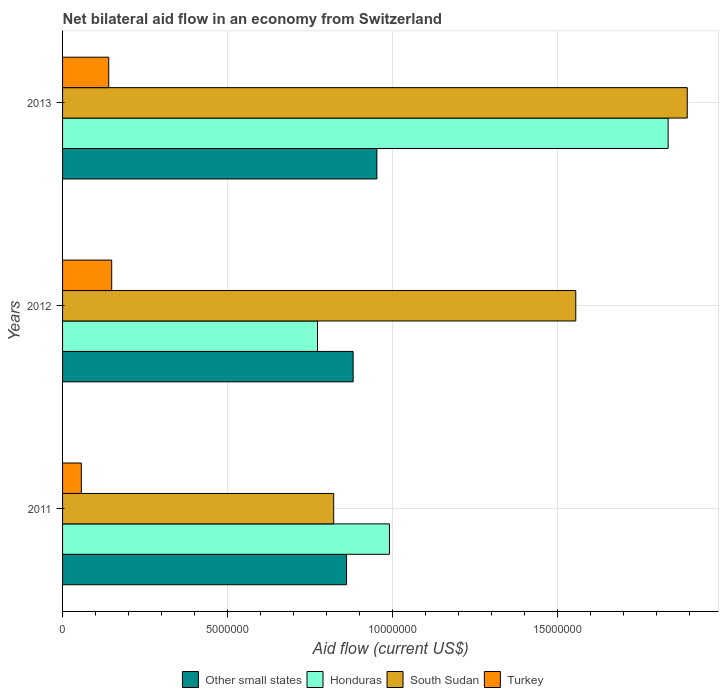How many groups of bars are there?
Provide a succinct answer. 3. Are the number of bars per tick equal to the number of legend labels?
Ensure brevity in your answer.  Yes. How many bars are there on the 3rd tick from the top?
Your answer should be compact. 4. How many bars are there on the 1st tick from the bottom?
Your answer should be compact. 4. What is the label of the 1st group of bars from the top?
Offer a terse response. 2013. What is the net bilateral aid flow in South Sudan in 2013?
Offer a terse response. 1.89e+07. Across all years, what is the maximum net bilateral aid flow in Honduras?
Offer a terse response. 1.84e+07. Across all years, what is the minimum net bilateral aid flow in Other small states?
Offer a very short reply. 8.61e+06. What is the total net bilateral aid flow in Honduras in the graph?
Provide a succinct answer. 3.60e+07. What is the difference between the net bilateral aid flow in Turkey in 2011 and that in 2013?
Your answer should be very brief. -8.30e+05. What is the difference between the net bilateral aid flow in Turkey in 2011 and the net bilateral aid flow in Honduras in 2012?
Ensure brevity in your answer.  -7.16e+06. In the year 2013, what is the difference between the net bilateral aid flow in Turkey and net bilateral aid flow in Honduras?
Your response must be concise. -1.70e+07. In how many years, is the net bilateral aid flow in South Sudan greater than 8000000 US$?
Give a very brief answer. 3. What is the ratio of the net bilateral aid flow in Turkey in 2011 to that in 2012?
Your answer should be very brief. 0.38. Is the net bilateral aid flow in South Sudan in 2011 less than that in 2013?
Provide a succinct answer. Yes. Is the difference between the net bilateral aid flow in Turkey in 2012 and 2013 greater than the difference between the net bilateral aid flow in Honduras in 2012 and 2013?
Your answer should be compact. Yes. What is the difference between the highest and the second highest net bilateral aid flow in Honduras?
Make the answer very short. 8.45e+06. What is the difference between the highest and the lowest net bilateral aid flow in South Sudan?
Offer a very short reply. 1.07e+07. What does the 4th bar from the top in 2011 represents?
Your response must be concise. Other small states. Is it the case that in every year, the sum of the net bilateral aid flow in Turkey and net bilateral aid flow in Honduras is greater than the net bilateral aid flow in Other small states?
Your answer should be compact. Yes. Are all the bars in the graph horizontal?
Make the answer very short. Yes. What is the difference between two consecutive major ticks on the X-axis?
Make the answer very short. 5.00e+06. Are the values on the major ticks of X-axis written in scientific E-notation?
Ensure brevity in your answer.  No. Does the graph contain grids?
Your answer should be very brief. Yes. Where does the legend appear in the graph?
Provide a short and direct response. Bottom center. How are the legend labels stacked?
Keep it short and to the point. Horizontal. What is the title of the graph?
Your answer should be compact. Net bilateral aid flow in an economy from Switzerland. What is the label or title of the Y-axis?
Keep it short and to the point. Years. What is the Aid flow (current US$) in Other small states in 2011?
Ensure brevity in your answer.  8.61e+06. What is the Aid flow (current US$) in Honduras in 2011?
Ensure brevity in your answer.  9.91e+06. What is the Aid flow (current US$) in South Sudan in 2011?
Your answer should be very brief. 8.22e+06. What is the Aid flow (current US$) in Turkey in 2011?
Keep it short and to the point. 5.70e+05. What is the Aid flow (current US$) of Other small states in 2012?
Your answer should be compact. 8.81e+06. What is the Aid flow (current US$) of Honduras in 2012?
Provide a succinct answer. 7.73e+06. What is the Aid flow (current US$) of South Sudan in 2012?
Make the answer very short. 1.56e+07. What is the Aid flow (current US$) of Turkey in 2012?
Your answer should be very brief. 1.49e+06. What is the Aid flow (current US$) in Other small states in 2013?
Your response must be concise. 9.53e+06. What is the Aid flow (current US$) of Honduras in 2013?
Your response must be concise. 1.84e+07. What is the Aid flow (current US$) of South Sudan in 2013?
Provide a short and direct response. 1.89e+07. What is the Aid flow (current US$) in Turkey in 2013?
Your response must be concise. 1.40e+06. Across all years, what is the maximum Aid flow (current US$) in Other small states?
Offer a very short reply. 9.53e+06. Across all years, what is the maximum Aid flow (current US$) of Honduras?
Provide a short and direct response. 1.84e+07. Across all years, what is the maximum Aid flow (current US$) in South Sudan?
Provide a short and direct response. 1.89e+07. Across all years, what is the maximum Aid flow (current US$) in Turkey?
Give a very brief answer. 1.49e+06. Across all years, what is the minimum Aid flow (current US$) in Other small states?
Ensure brevity in your answer.  8.61e+06. Across all years, what is the minimum Aid flow (current US$) of Honduras?
Offer a very short reply. 7.73e+06. Across all years, what is the minimum Aid flow (current US$) in South Sudan?
Give a very brief answer. 8.22e+06. Across all years, what is the minimum Aid flow (current US$) in Turkey?
Make the answer very short. 5.70e+05. What is the total Aid flow (current US$) of Other small states in the graph?
Your answer should be very brief. 2.70e+07. What is the total Aid flow (current US$) in Honduras in the graph?
Keep it short and to the point. 3.60e+07. What is the total Aid flow (current US$) in South Sudan in the graph?
Offer a very short reply. 4.27e+07. What is the total Aid flow (current US$) in Turkey in the graph?
Keep it short and to the point. 3.46e+06. What is the difference between the Aid flow (current US$) in Honduras in 2011 and that in 2012?
Your answer should be compact. 2.18e+06. What is the difference between the Aid flow (current US$) in South Sudan in 2011 and that in 2012?
Keep it short and to the point. -7.34e+06. What is the difference between the Aid flow (current US$) in Turkey in 2011 and that in 2012?
Your response must be concise. -9.20e+05. What is the difference between the Aid flow (current US$) in Other small states in 2011 and that in 2013?
Your response must be concise. -9.20e+05. What is the difference between the Aid flow (current US$) of Honduras in 2011 and that in 2013?
Offer a terse response. -8.45e+06. What is the difference between the Aid flow (current US$) of South Sudan in 2011 and that in 2013?
Your answer should be compact. -1.07e+07. What is the difference between the Aid flow (current US$) in Turkey in 2011 and that in 2013?
Offer a very short reply. -8.30e+05. What is the difference between the Aid flow (current US$) of Other small states in 2012 and that in 2013?
Provide a short and direct response. -7.20e+05. What is the difference between the Aid flow (current US$) in Honduras in 2012 and that in 2013?
Keep it short and to the point. -1.06e+07. What is the difference between the Aid flow (current US$) of South Sudan in 2012 and that in 2013?
Keep it short and to the point. -3.38e+06. What is the difference between the Aid flow (current US$) in Other small states in 2011 and the Aid flow (current US$) in Honduras in 2012?
Keep it short and to the point. 8.80e+05. What is the difference between the Aid flow (current US$) of Other small states in 2011 and the Aid flow (current US$) of South Sudan in 2012?
Your answer should be compact. -6.95e+06. What is the difference between the Aid flow (current US$) of Other small states in 2011 and the Aid flow (current US$) of Turkey in 2012?
Your response must be concise. 7.12e+06. What is the difference between the Aid flow (current US$) of Honduras in 2011 and the Aid flow (current US$) of South Sudan in 2012?
Offer a terse response. -5.65e+06. What is the difference between the Aid flow (current US$) in Honduras in 2011 and the Aid flow (current US$) in Turkey in 2012?
Provide a succinct answer. 8.42e+06. What is the difference between the Aid flow (current US$) in South Sudan in 2011 and the Aid flow (current US$) in Turkey in 2012?
Your answer should be very brief. 6.73e+06. What is the difference between the Aid flow (current US$) in Other small states in 2011 and the Aid flow (current US$) in Honduras in 2013?
Give a very brief answer. -9.75e+06. What is the difference between the Aid flow (current US$) in Other small states in 2011 and the Aid flow (current US$) in South Sudan in 2013?
Offer a terse response. -1.03e+07. What is the difference between the Aid flow (current US$) of Other small states in 2011 and the Aid flow (current US$) of Turkey in 2013?
Provide a succinct answer. 7.21e+06. What is the difference between the Aid flow (current US$) of Honduras in 2011 and the Aid flow (current US$) of South Sudan in 2013?
Keep it short and to the point. -9.03e+06. What is the difference between the Aid flow (current US$) of Honduras in 2011 and the Aid flow (current US$) of Turkey in 2013?
Provide a short and direct response. 8.51e+06. What is the difference between the Aid flow (current US$) of South Sudan in 2011 and the Aid flow (current US$) of Turkey in 2013?
Provide a succinct answer. 6.82e+06. What is the difference between the Aid flow (current US$) in Other small states in 2012 and the Aid flow (current US$) in Honduras in 2013?
Make the answer very short. -9.55e+06. What is the difference between the Aid flow (current US$) of Other small states in 2012 and the Aid flow (current US$) of South Sudan in 2013?
Offer a terse response. -1.01e+07. What is the difference between the Aid flow (current US$) in Other small states in 2012 and the Aid flow (current US$) in Turkey in 2013?
Ensure brevity in your answer.  7.41e+06. What is the difference between the Aid flow (current US$) in Honduras in 2012 and the Aid flow (current US$) in South Sudan in 2013?
Your response must be concise. -1.12e+07. What is the difference between the Aid flow (current US$) in Honduras in 2012 and the Aid flow (current US$) in Turkey in 2013?
Offer a terse response. 6.33e+06. What is the difference between the Aid flow (current US$) of South Sudan in 2012 and the Aid flow (current US$) of Turkey in 2013?
Offer a very short reply. 1.42e+07. What is the average Aid flow (current US$) of Other small states per year?
Make the answer very short. 8.98e+06. What is the average Aid flow (current US$) of Honduras per year?
Your answer should be compact. 1.20e+07. What is the average Aid flow (current US$) in South Sudan per year?
Your answer should be very brief. 1.42e+07. What is the average Aid flow (current US$) of Turkey per year?
Give a very brief answer. 1.15e+06. In the year 2011, what is the difference between the Aid flow (current US$) in Other small states and Aid flow (current US$) in Honduras?
Your response must be concise. -1.30e+06. In the year 2011, what is the difference between the Aid flow (current US$) in Other small states and Aid flow (current US$) in Turkey?
Your answer should be compact. 8.04e+06. In the year 2011, what is the difference between the Aid flow (current US$) of Honduras and Aid flow (current US$) of South Sudan?
Keep it short and to the point. 1.69e+06. In the year 2011, what is the difference between the Aid flow (current US$) of Honduras and Aid flow (current US$) of Turkey?
Keep it short and to the point. 9.34e+06. In the year 2011, what is the difference between the Aid flow (current US$) of South Sudan and Aid flow (current US$) of Turkey?
Your answer should be very brief. 7.65e+06. In the year 2012, what is the difference between the Aid flow (current US$) of Other small states and Aid flow (current US$) of Honduras?
Give a very brief answer. 1.08e+06. In the year 2012, what is the difference between the Aid flow (current US$) of Other small states and Aid flow (current US$) of South Sudan?
Offer a terse response. -6.75e+06. In the year 2012, what is the difference between the Aid flow (current US$) of Other small states and Aid flow (current US$) of Turkey?
Your response must be concise. 7.32e+06. In the year 2012, what is the difference between the Aid flow (current US$) in Honduras and Aid flow (current US$) in South Sudan?
Make the answer very short. -7.83e+06. In the year 2012, what is the difference between the Aid flow (current US$) in Honduras and Aid flow (current US$) in Turkey?
Provide a short and direct response. 6.24e+06. In the year 2012, what is the difference between the Aid flow (current US$) in South Sudan and Aid flow (current US$) in Turkey?
Your answer should be compact. 1.41e+07. In the year 2013, what is the difference between the Aid flow (current US$) of Other small states and Aid flow (current US$) of Honduras?
Your response must be concise. -8.83e+06. In the year 2013, what is the difference between the Aid flow (current US$) in Other small states and Aid flow (current US$) in South Sudan?
Your response must be concise. -9.41e+06. In the year 2013, what is the difference between the Aid flow (current US$) in Other small states and Aid flow (current US$) in Turkey?
Offer a terse response. 8.13e+06. In the year 2013, what is the difference between the Aid flow (current US$) in Honduras and Aid flow (current US$) in South Sudan?
Give a very brief answer. -5.80e+05. In the year 2013, what is the difference between the Aid flow (current US$) of Honduras and Aid flow (current US$) of Turkey?
Your answer should be compact. 1.70e+07. In the year 2013, what is the difference between the Aid flow (current US$) in South Sudan and Aid flow (current US$) in Turkey?
Ensure brevity in your answer.  1.75e+07. What is the ratio of the Aid flow (current US$) of Other small states in 2011 to that in 2012?
Provide a succinct answer. 0.98. What is the ratio of the Aid flow (current US$) in Honduras in 2011 to that in 2012?
Your answer should be compact. 1.28. What is the ratio of the Aid flow (current US$) in South Sudan in 2011 to that in 2012?
Offer a terse response. 0.53. What is the ratio of the Aid flow (current US$) of Turkey in 2011 to that in 2012?
Offer a very short reply. 0.38. What is the ratio of the Aid flow (current US$) in Other small states in 2011 to that in 2013?
Ensure brevity in your answer.  0.9. What is the ratio of the Aid flow (current US$) in Honduras in 2011 to that in 2013?
Offer a terse response. 0.54. What is the ratio of the Aid flow (current US$) of South Sudan in 2011 to that in 2013?
Offer a very short reply. 0.43. What is the ratio of the Aid flow (current US$) of Turkey in 2011 to that in 2013?
Offer a terse response. 0.41. What is the ratio of the Aid flow (current US$) in Other small states in 2012 to that in 2013?
Provide a short and direct response. 0.92. What is the ratio of the Aid flow (current US$) of Honduras in 2012 to that in 2013?
Offer a very short reply. 0.42. What is the ratio of the Aid flow (current US$) in South Sudan in 2012 to that in 2013?
Give a very brief answer. 0.82. What is the ratio of the Aid flow (current US$) in Turkey in 2012 to that in 2013?
Your answer should be compact. 1.06. What is the difference between the highest and the second highest Aid flow (current US$) of Other small states?
Provide a succinct answer. 7.20e+05. What is the difference between the highest and the second highest Aid flow (current US$) of Honduras?
Keep it short and to the point. 8.45e+06. What is the difference between the highest and the second highest Aid flow (current US$) in South Sudan?
Provide a short and direct response. 3.38e+06. What is the difference between the highest and the second highest Aid flow (current US$) of Turkey?
Offer a very short reply. 9.00e+04. What is the difference between the highest and the lowest Aid flow (current US$) of Other small states?
Make the answer very short. 9.20e+05. What is the difference between the highest and the lowest Aid flow (current US$) in Honduras?
Give a very brief answer. 1.06e+07. What is the difference between the highest and the lowest Aid flow (current US$) in South Sudan?
Your response must be concise. 1.07e+07. What is the difference between the highest and the lowest Aid flow (current US$) of Turkey?
Your answer should be very brief. 9.20e+05. 